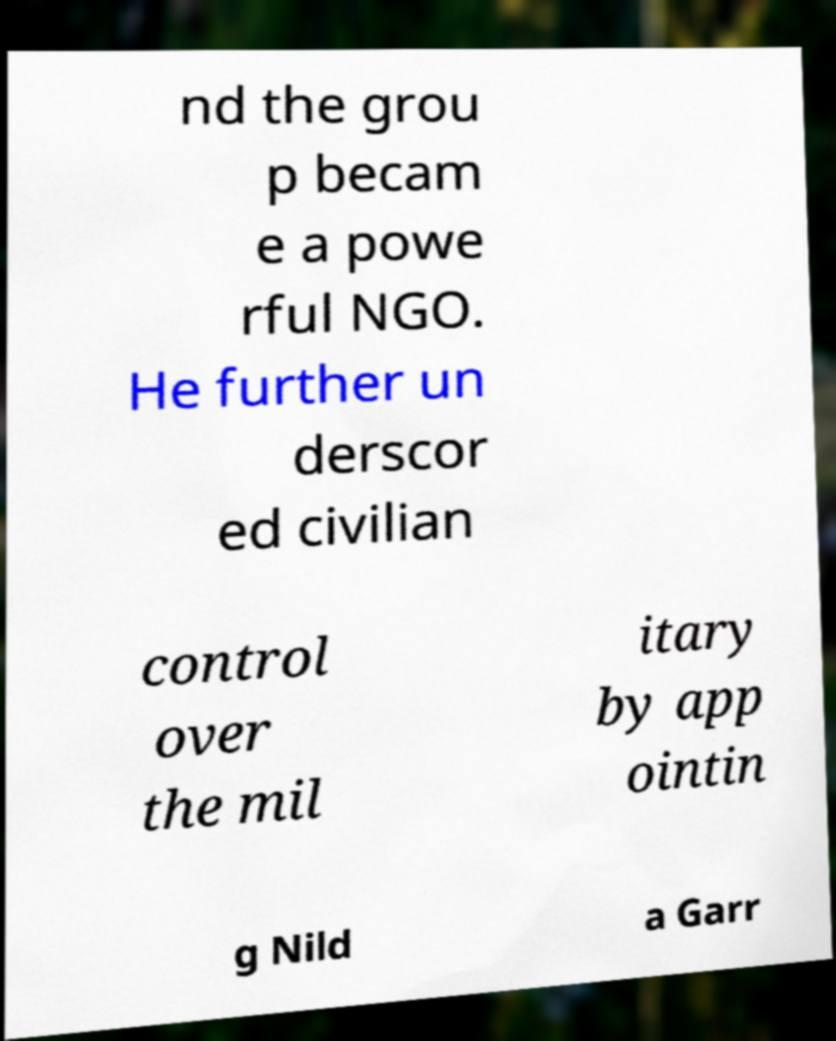For documentation purposes, I need the text within this image transcribed. Could you provide that? nd the grou p becam e a powe rful NGO. He further un derscor ed civilian control over the mil itary by app ointin g Nild a Garr 